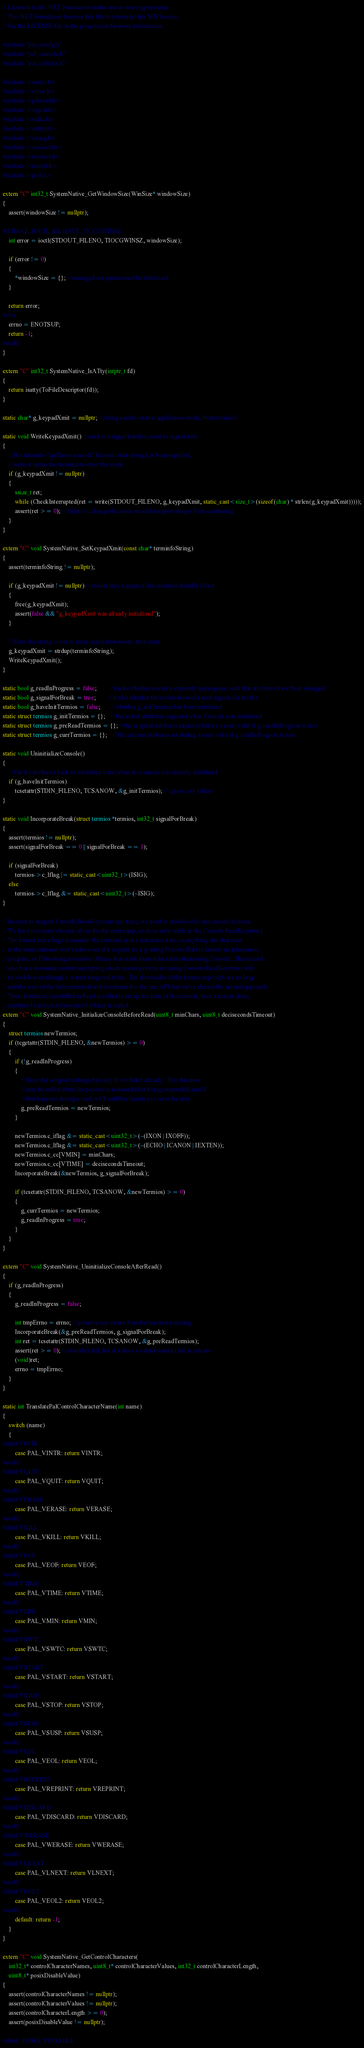<code> <loc_0><loc_0><loc_500><loc_500><_C++_>// Licensed to the .NET Foundation under one or more agreements.
// The .NET Foundation licenses this file to you under the MIT license.
// See the LICENSE file in the project root for more information.

#include "pal_config.h"
#include "pal_console.h"
#include "pal_utilities.h"

#include <assert.h>
#include <errno.h>
#include <pthread.h>
#include <signal.h>
#include <stdio.h>
#include <stdlib.h>
#include <string.h>
#include <sys/ioctl.h>
#include <termios.h>
#include <unistd.h>
#include <poll.h>

extern "C" int32_t SystemNative_GetWindowSize(WinSize* windowSize)
{
    assert(windowSize != nullptr);

#if HAVE_IOCTL && HAVE_TIOCGWINSZ
    int error = ioctl(STDOUT_FILENO, TIOCGWINSZ, windowSize);

    if (error != 0)
    {
        *windowSize = {}; // managed out param must be initialized
    }

    return error;
#else
    errno = ENOTSUP;
    return -1;
#endif
}

extern "C" int32_t SystemNative_IsATty(intptr_t fd)
{
    return isatty(ToFileDescriptor(fd));
}

static char* g_keypadXmit = nullptr; // string used to enable application mode, from terminfo

static void WriteKeypadXmit() // used in a signal handler, must be signal-safe
{
    // If a terminfo "application mode" keypad_xmit string has been supplied,
    // write it out to the terminal to enter the mode.
    if (g_keypadXmit != nullptr)
    {
        ssize_t ret;
        while (CheckInterrupted(ret = write(STDOUT_FILENO, g_keypadXmit, static_cast<size_t>(sizeof(char) * strlen(g_keypadXmit)))));
        assert(ret >= 0); // failure to change the mode should not prevent app from continuing
    }
}

extern "C" void SystemNative_SetKeypadXmit(const char* terminfoString)
{
    assert(terminfoString != nullptr);

    if (g_keypadXmit != nullptr) // should only happen if initialization initially failed
    {
        free(g_keypadXmit);
        assert(false && "g_keypadXmit was already initialized");
    }

    // Store the string to use to enter application mode, then enter
    g_keypadXmit = strdup(terminfoString);
    WriteKeypadXmit();
}

static bool g_readInProgress = false;        // tracks whether a read is currently in progress, such that attributes have been changed
static bool g_signalForBreak = true;        // tracks whether the terminal should send signals for breaks
static bool g_haveInitTermios = false;       // whether g_initTermios has been initialized
static struct termios g_initTermios = {};    // the initial attributes captured when Console was initialized
static struct termios g_preReadTermios = {}; // the original attributes captured before a read; valid if g_readInProgress is true
static struct termios g_currTermios = {};    // the current attributes set during a read; valid if g_readInProgress is true

static void UninitializeConsole()
{
    // Put the attributes back to what they were when the console was initially initialized
    if (g_haveInitTermios)
        tcsetattr(STDIN_FILENO, TCSANOW, &g_initTermios); // ignore any failure
}

static void IncorporateBreak(struct termios *termios, int32_t signalForBreak)
{
    assert(termios != nullptr);
    assert(signalForBreak == 0 || signalForBreak == 1);

    if (signalForBreak)
        termios->c_lflag |= static_cast<uint32_t>(ISIG);
    else
        termios->c_lflag &= static_cast<uint32_t>(~ISIG);
}

// In order to support Console.ReadKey(intecept: true), we need to disable echo and canonical mode.
// We have two main choices: do so for the entire app, or do so only while in the Console.ReadKey(true).
// The former has a huge downside: the terminal is in a non-echo state, so anything else that runs
// in the same terminal won't echo even if it expects to, e.g. using Process.Start to launch an interactive,
// program, or P/Invoking to a native library that reads from stdin rather than using Console.  The second
// also has a downside, in that any typing which occurs prior to invoking Console.ReadKey(true) will
// be visible even though it wasn't supposed to be.  The downsides of the former approach are so large
// and the cons of the latter minimal and constrained to the one API that we've chosen the second approach.
// Thus, InitializeConsoleBeforeRead is called to set up the state of the console, then a read is done,
// and then UninitializeConsoleAfterRead is called.
extern "C" void SystemNative_InitializeConsoleBeforeRead(uint8_t minChars, uint8_t decisecondsTimeout)
{
    struct termios newTermios;
    if (tcgetattr(STDIN_FILENO, &newTermios) >= 0)
    {
        if (!g_readInProgress)
        {
            // Store the original settings, but only if we didn't already.  This function
            // may be called when the process is resumed after being suspended, and if
            // that happens during a read, we'll call this function to reset the attrs.
            g_preReadTermios = newTermios;
        }

        newTermios.c_iflag &= static_cast<uint32_t>(~(IXON | IXOFF));
        newTermios.c_lflag &= static_cast<uint32_t>(~(ECHO | ICANON | IEXTEN));
        newTermios.c_cc[VMIN] = minChars;
        newTermios.c_cc[VTIME] = decisecondsTimeout;
        IncorporateBreak(&newTermios, g_signalForBreak);

        if (tcsetattr(STDIN_FILENO, TCSANOW, &newTermios) >= 0)
        {
            g_currTermios = newTermios;
            g_readInProgress = true;
        }
    }
}

extern "C" void SystemNative_UninitializeConsoleAfterRead()
{
    if (g_readInProgress)
    {
        g_readInProgress = false;

        int tmpErrno = errno; // preserve any errors from before uninitializing
        IncorporateBreak(&g_preReadTermios, g_signalForBreak);
        int ret = tcsetattr(STDIN_FILENO, TCSANOW, &g_preReadTermios);
        assert(ret >= 0); // shouldn't fail, but if it does we don't want to fail in release
        (void)ret;
        errno = tmpErrno;
    }
}

static int TranslatePalControlCharacterName(int name)
{
    switch (name)
    {
#ifdef VINTR
        case PAL_VINTR: return VINTR;
#endif
#ifdef VQUIT
        case PAL_VQUIT: return VQUIT;
#endif
#ifdef VERASE
        case PAL_VERASE: return VERASE;
#endif
#ifdef VKILL
        case PAL_VKILL: return VKILL;
#endif
#ifdef VEOF
        case PAL_VEOF: return VEOF;
#endif
#ifdef VTIME
        case PAL_VTIME: return VTIME;
#endif
#ifdef VMIN
        case PAL_VMIN: return VMIN;
#endif
#ifdef VSWTC
        case PAL_VSWTC: return VSWTC;
#endif
#ifdef VSTART
        case PAL_VSTART: return VSTART;
#endif
#ifdef VSTOP
        case PAL_VSTOP: return VSTOP;
#endif
#ifdef VSUSP
        case PAL_VSUSP: return VSUSP;
#endif
#ifdef VEOL
        case PAL_VEOL: return VEOL;
#endif
#ifdef VREPRINT
        case PAL_VREPRINT: return VREPRINT;
#endif
#ifdef VDISCARD
        case PAL_VDISCARD: return VDISCARD;
#endif
#ifdef VWERASE
        case PAL_VWERASE: return VWERASE;
#endif
#ifdef VLNEXT
        case PAL_VLNEXT: return VLNEXT;
#endif
#ifdef VEOL2
        case PAL_VEOL2: return VEOL2;
#endif
        default: return -1;
    }
}

extern "C" void SystemNative_GetControlCharacters(
    int32_t* controlCharacterNames, uint8_t* controlCharacterValues, int32_t controlCharacterLength,
    uint8_t* posixDisableValue)
{
    assert(controlCharacterNames != nullptr);
    assert(controlCharacterValues != nullptr);
    assert(controlCharacterLength >= 0);
    assert(posixDisableValue != nullptr);

#ifdef _POSIX_VDISABLE</code> 